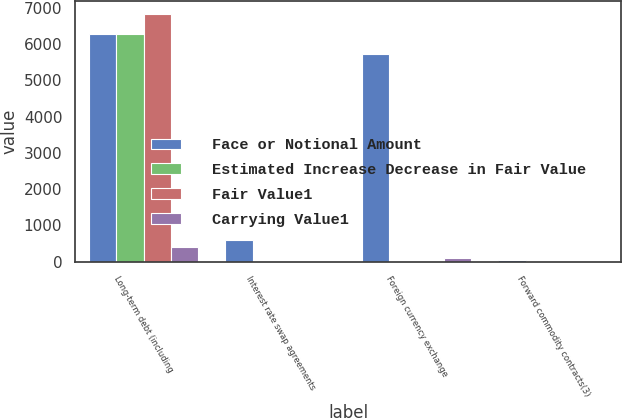Convert chart to OTSL. <chart><loc_0><loc_0><loc_500><loc_500><stacked_bar_chart><ecel><fcel>Long-term debt (including<fcel>Interest rate swap agreements<fcel>Foreign currency exchange<fcel>Forward commodity contracts(3)<nl><fcel>Face or Notional Amount<fcel>6278<fcel>600<fcel>5733<fcel>52<nl><fcel>Estimated Increase Decrease in Fair Value<fcel>6278<fcel>22<fcel>2<fcel>4<nl><fcel>Fair Value1<fcel>6835<fcel>22<fcel>2<fcel>4<nl><fcel>Carrying Value1<fcel>399<fcel>18<fcel>102<fcel>10<nl></chart> 